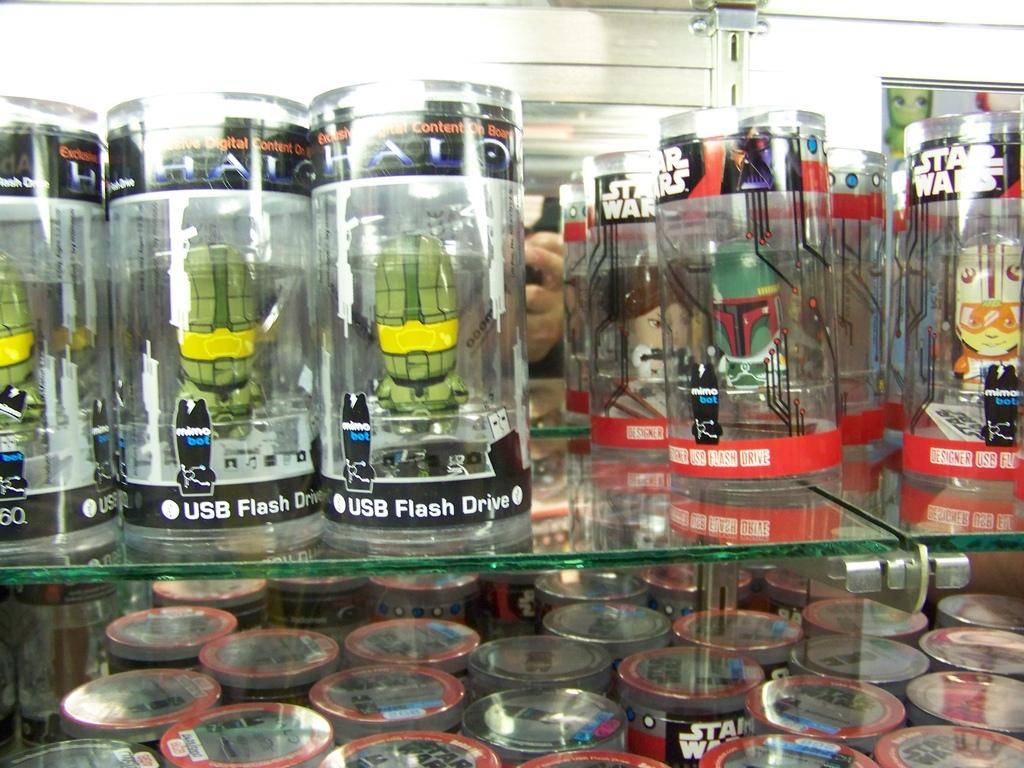<image>
Summarize the visual content of the image. Star Wars toys are on glass shelves in rows. 